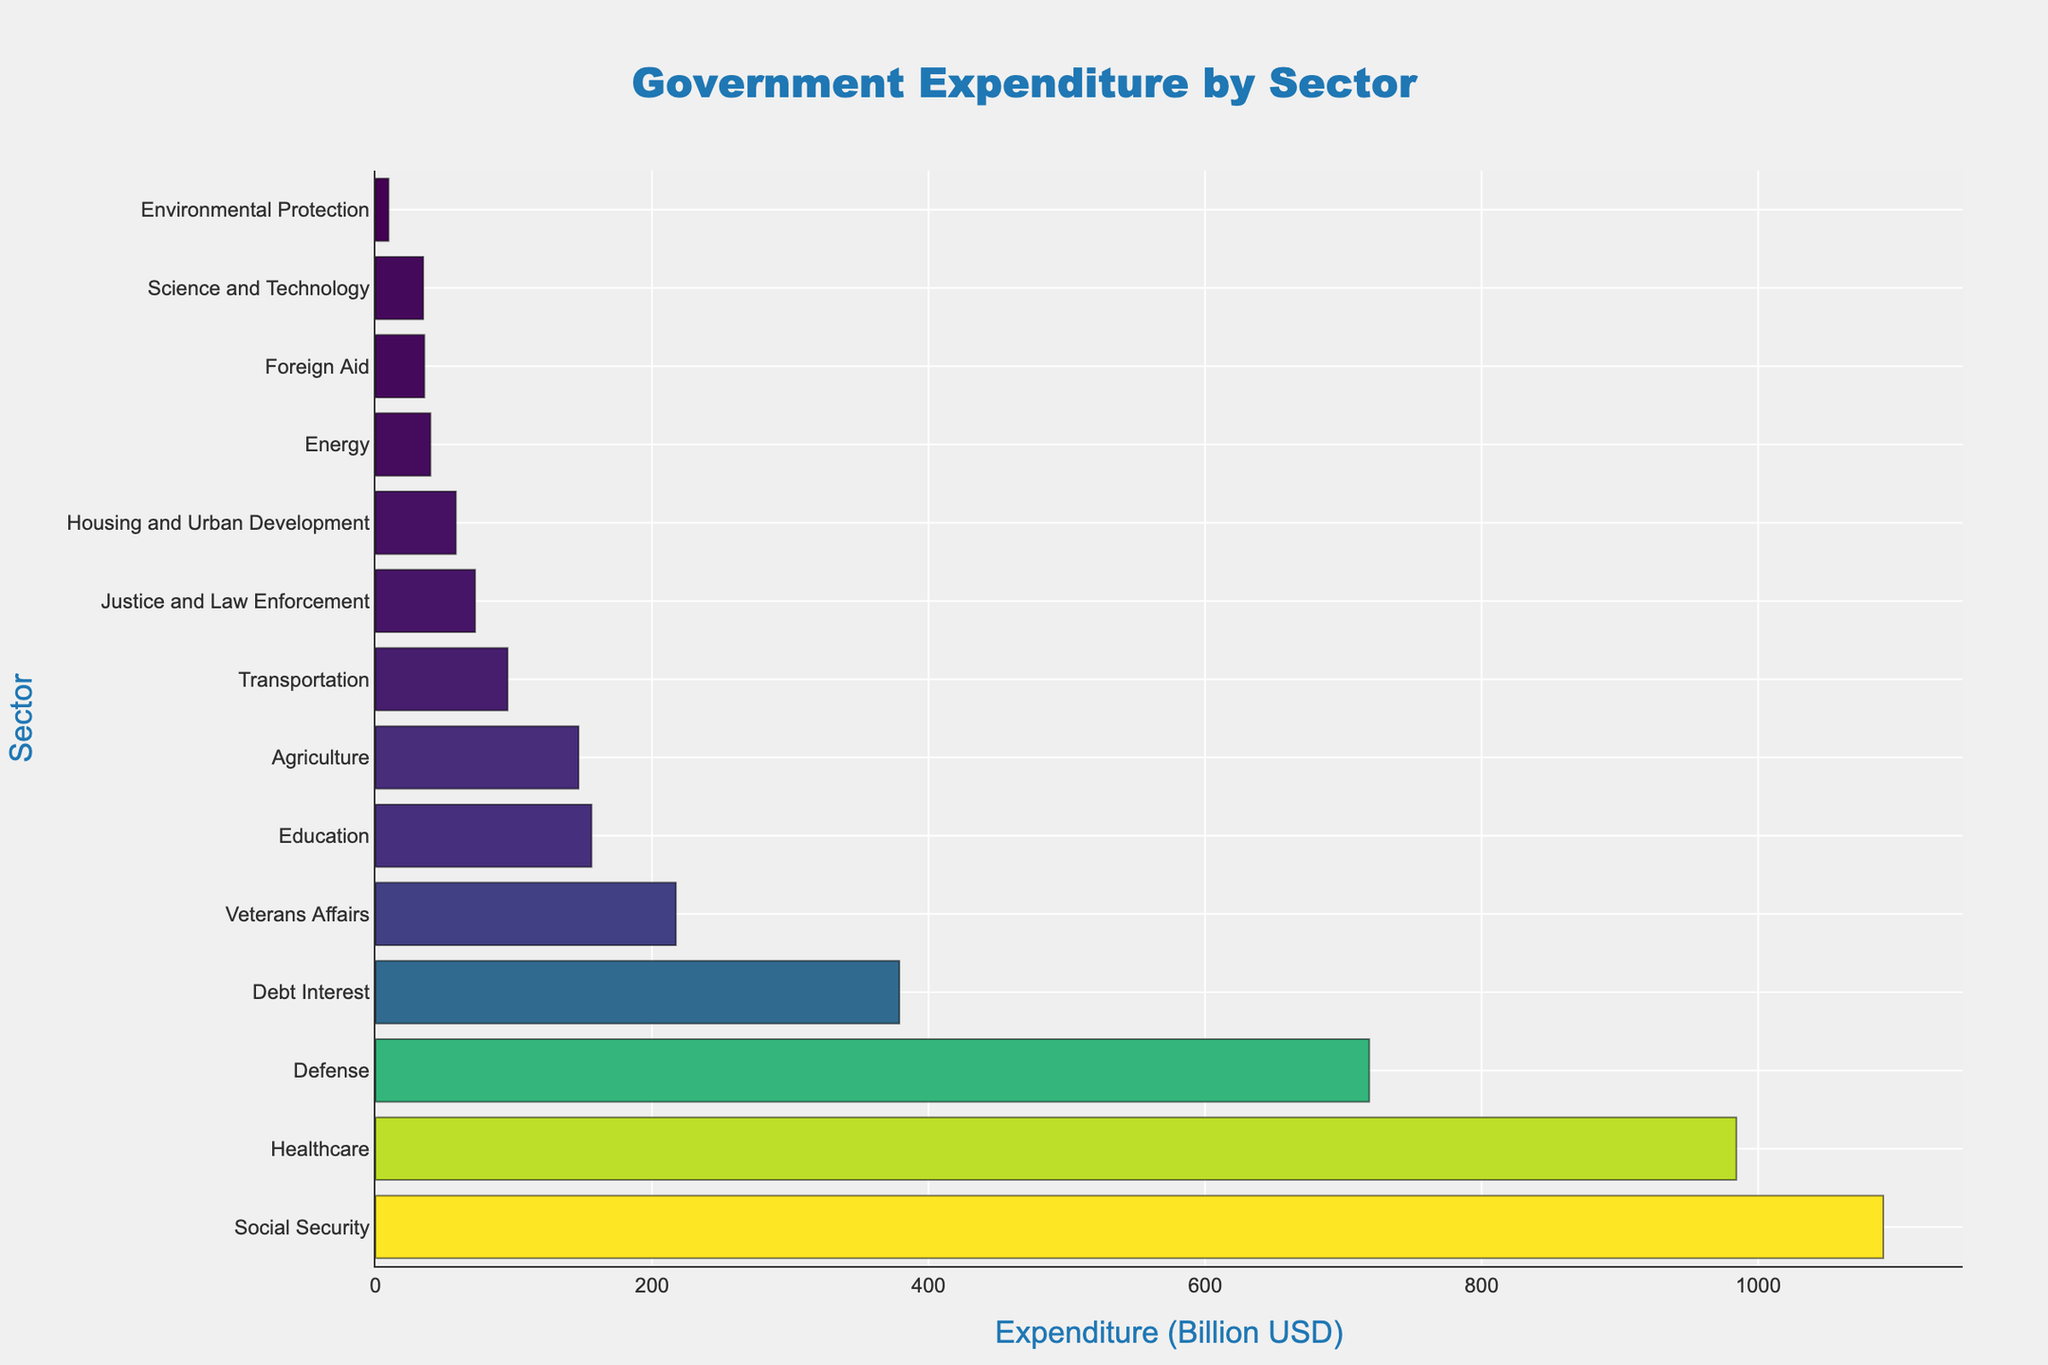What's the sector with the highest expenditure? The sector with the highest expenditure can be identified by looking at the bar representing the sector with the longest length on the horizontal axis. The "Social Security" bar extends the furthest to the right.
Answer: Social Security Which two sectors have the lowest expenditures combined? To find the two sectors with the lowest expenditures, look for the two shortest bars. The shortest bars correspond to "Environmental Protection" and "Science and Technology". Summing their expenditures: 9.5 + 34.6 = 44.1 billion USD.
Answer: Environmental Protection and Science and Technology, 44.1 billion USD Which sector's expenditure is closest to 200 billion USD? Compare the lengths of the bars to determine which expenditure value is near 200 billion USD. The bar for "Veterans Affairs" is closest to this amount, with an expenditure of 217.3 billion USD.
Answer: Veterans Affairs How much more does the government spend on Healthcare compared to Education? Find the expenditure values for both sectors and subtract the smaller from the larger. Healthcare: 984.2 billion USD, Education: 156.3 billion USD. So, 984.2 - 156.3 = 827.9 billion USD.
Answer: 827.9 billion USD How does the expenditure on Social Security compare to the total expenditure on Healthcare and Defense combined? Find the expenditure values for all three sectors and compare. Social Security: 1090.5 billion USD, Healthcare: 984.2 billion USD, Defense: 718.7 billion USD. Combined expenditure on Healthcare and Defense: 984.2 + 718.7 = 1702.9 billion USD. Social Security expenditure is less than the combined expenditure on Healthcare and Defense.
Answer: Social Security is less than Healthcare and Defense combined What's the average expenditure of Agriculture, Energy, and Foreign Aid sectors? Average is calculated by summing the expenditures and dividing by the number of sectors. Agriculture: 146.9, Energy: 39.8, Foreign Aid: 35.4. Sum = 146.9 + 39.8 + 35.4 = 222.1. So, the average expenditure = 222.1 / 3 = 74.03 billion USD.
Answer: 74.03 billion USD Which sector shows a marked increase from Housing and Urban Development? Identify the sectors adjacent to "Housing and Urban Development" and compare their expenditure values. The next higher is "Veterans Affairs" with 217.3 billion USD; it shows a significant increase from "Housing and Urban Development" with 58.2 billion USD.
Answer: Veterans Affairs What's the total expenditure on Social Security, Education, and Transportation sectors? Sum the expenditure values for these three sectors. Social Security: 1090.5, Education: 156.3, Transportation: 95.6. The total expenditure is 1090.5 + 156.3 + 95.6 = 1342.4 billion USD.
Answer: 1342.4 billion USD How does the expenditure on Debt Interest compare relative to Veterans Affairs? Find the expenditures for both sectors and calculate their difference. Debt Interest: 378.9 billion USD, Veterans Affairs: 217.3 billion USD. The ratio is 378.9 / 217.3 ≈ 1.74. So, Debt Interest expenditure is approximately 1.74 times that of Veterans Affairs.
Answer: Debt Interest is 1.74 times Veterans Affairs 